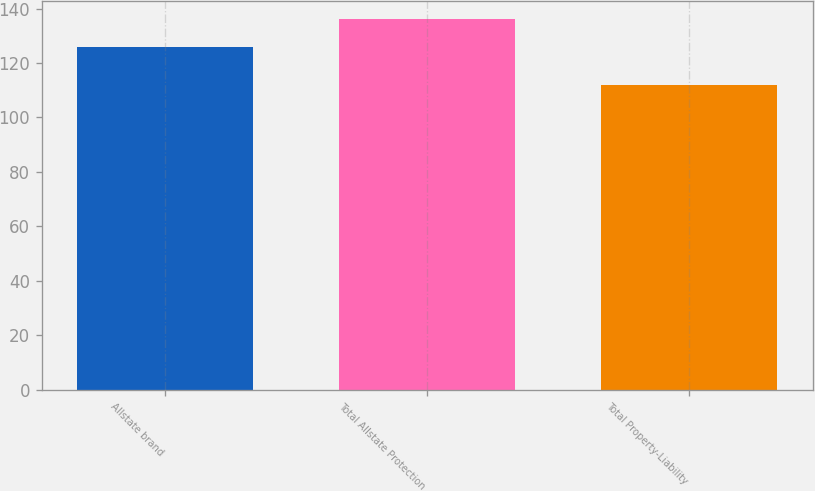Convert chart to OTSL. <chart><loc_0><loc_0><loc_500><loc_500><bar_chart><fcel>Allstate brand<fcel>Total Allstate Protection<fcel>Total Property-Liability<nl><fcel>126<fcel>136<fcel>112<nl></chart> 